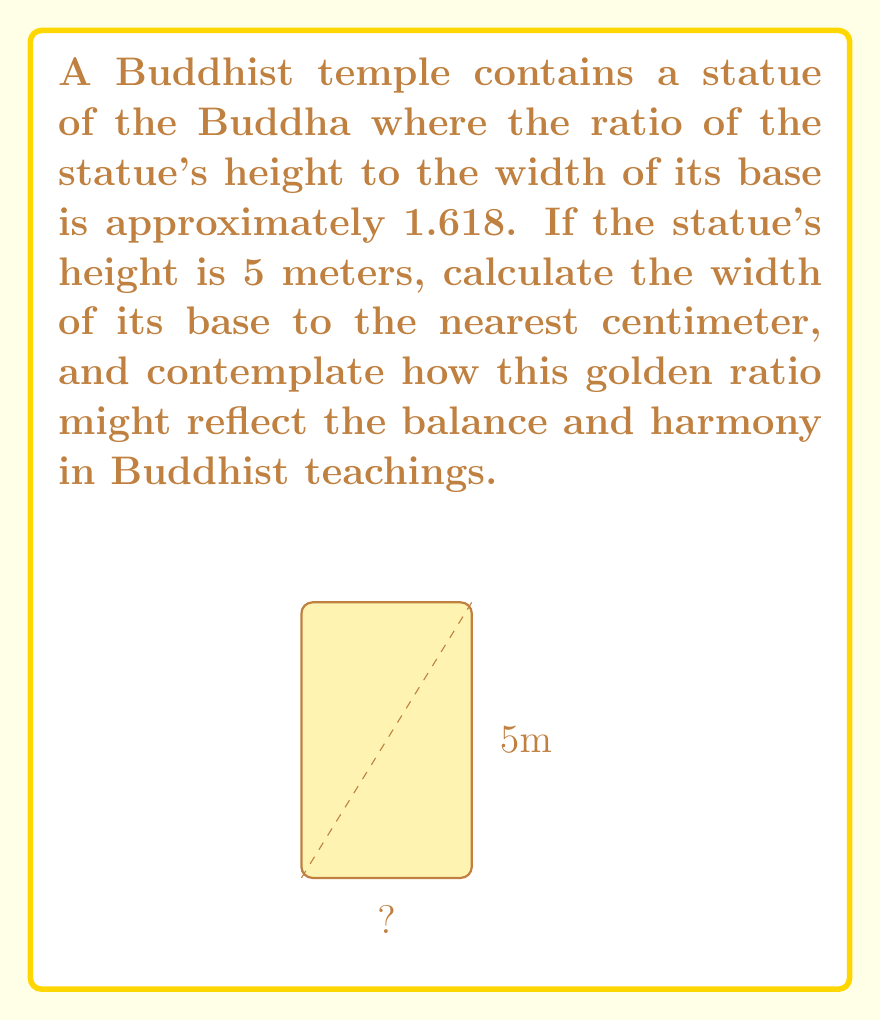Give your solution to this math problem. To solve this problem, we'll follow these steps:

1) The golden ratio, often denoted by φ (phi), is approximately 1.618. This ratio is given as the height to the width of the statue.

2) Let's define our variables:
   $h$ = height of the statue = 5 meters
   $w$ = width of the base (unknown)

3) We can express the golden ratio as an equation:
   $$\frac{h}{w} = φ ≈ 1.618$$

4) Substituting the known values:
   $$\frac{5}{w} ≈ 1.618$$

5) To solve for $w$, we multiply both sides by $w$:
   $$5 ≈ 1.618w$$

6) Now divide both sides by 1.618:
   $$\frac{5}{1.618} ≈ w$$

7) Calculate:
   $$w ≈ 3.090235...$$

8) Rounding to the nearest centimeter (0.01 m):
   $$w ≈ 3.09 \text{ meters}$$

This result shows how the golden ratio creates a harmonious proportion in the statue, potentially symbolizing the balance between earthly existence (the base) and spiritual enlightenment (the height) in Buddhist philosophy.
Answer: 3.09 m 